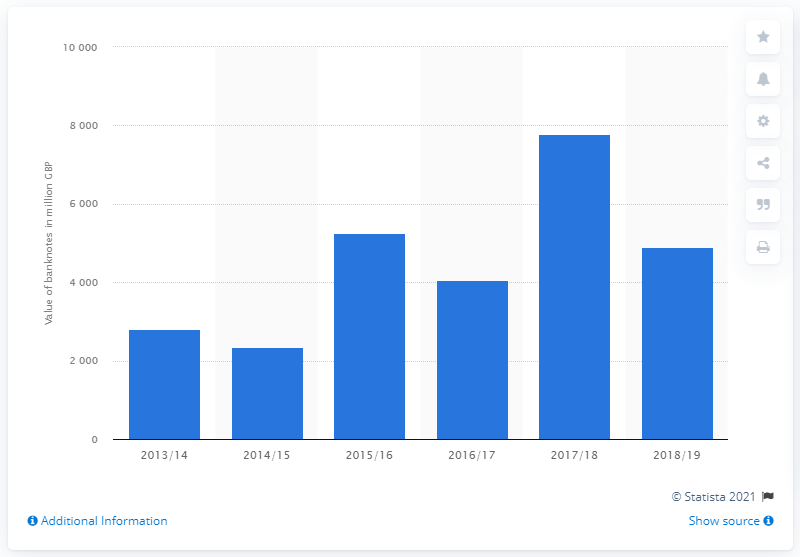Highlight a few significant elements in this photo. In 2018/2019, the Bank of England removed a total of 4,895 British pound banknotes from circulation and destroyed them. 